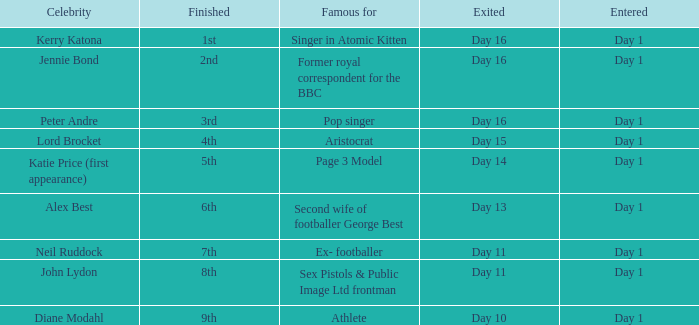Name the finished for kerry katona 1.0. 